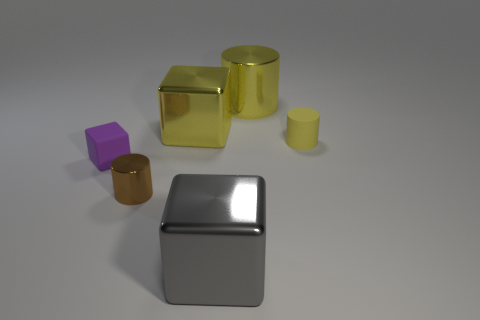Are there any purple cubes that have the same size as the yellow rubber cylinder?
Your response must be concise. Yes. Are there an equal number of tiny metallic cylinders that are left of the purple object and green metallic cylinders?
Provide a succinct answer. Yes. What size is the matte block?
Provide a short and direct response. Small. There is a metallic cube that is behind the yellow matte object; how many large gray cubes are behind it?
Your answer should be very brief. 0. There is a object that is to the left of the gray shiny thing and in front of the rubber cube; what shape is it?
Your response must be concise. Cylinder. How many other cylinders have the same color as the large metallic cylinder?
Your response must be concise. 1. Are there any large yellow metallic cylinders that are behind the large metal thing right of the shiny block in front of the yellow matte object?
Your answer should be compact. No. What size is the block that is behind the tiny brown object and to the right of the small purple matte cube?
Keep it short and to the point. Large. What number of gray cubes are made of the same material as the tiny yellow cylinder?
Your response must be concise. 0. What number of cylinders are big metal things or tiny yellow matte things?
Your answer should be compact. 2. 